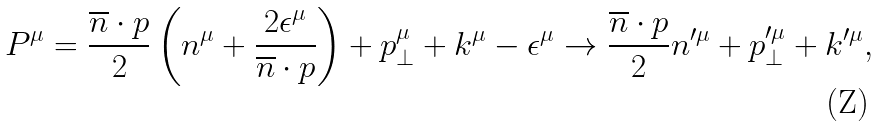<formula> <loc_0><loc_0><loc_500><loc_500>P ^ { \mu } = \frac { \overline { n } \cdot p } { 2 } \left ( n ^ { \mu } + \frac { 2 \epsilon ^ { \mu } } { \overline { n } \cdot p } \right ) + p _ { \perp } ^ { \mu } + k ^ { \mu } - \epsilon ^ { \mu } \rightarrow \frac { \overline { n } \cdot p } { 2 } n ^ { \prime \mu } + p _ { \perp } ^ { \prime \mu } + k ^ { \prime \mu } ,</formula> 